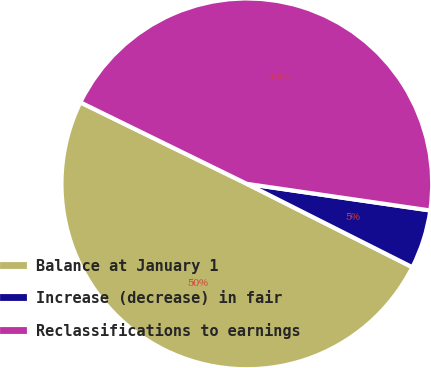Convert chart to OTSL. <chart><loc_0><loc_0><loc_500><loc_500><pie_chart><fcel>Balance at January 1<fcel>Increase (decrease) in fair<fcel>Reclassifications to earnings<nl><fcel>49.82%<fcel>5.13%<fcel>45.05%<nl></chart> 